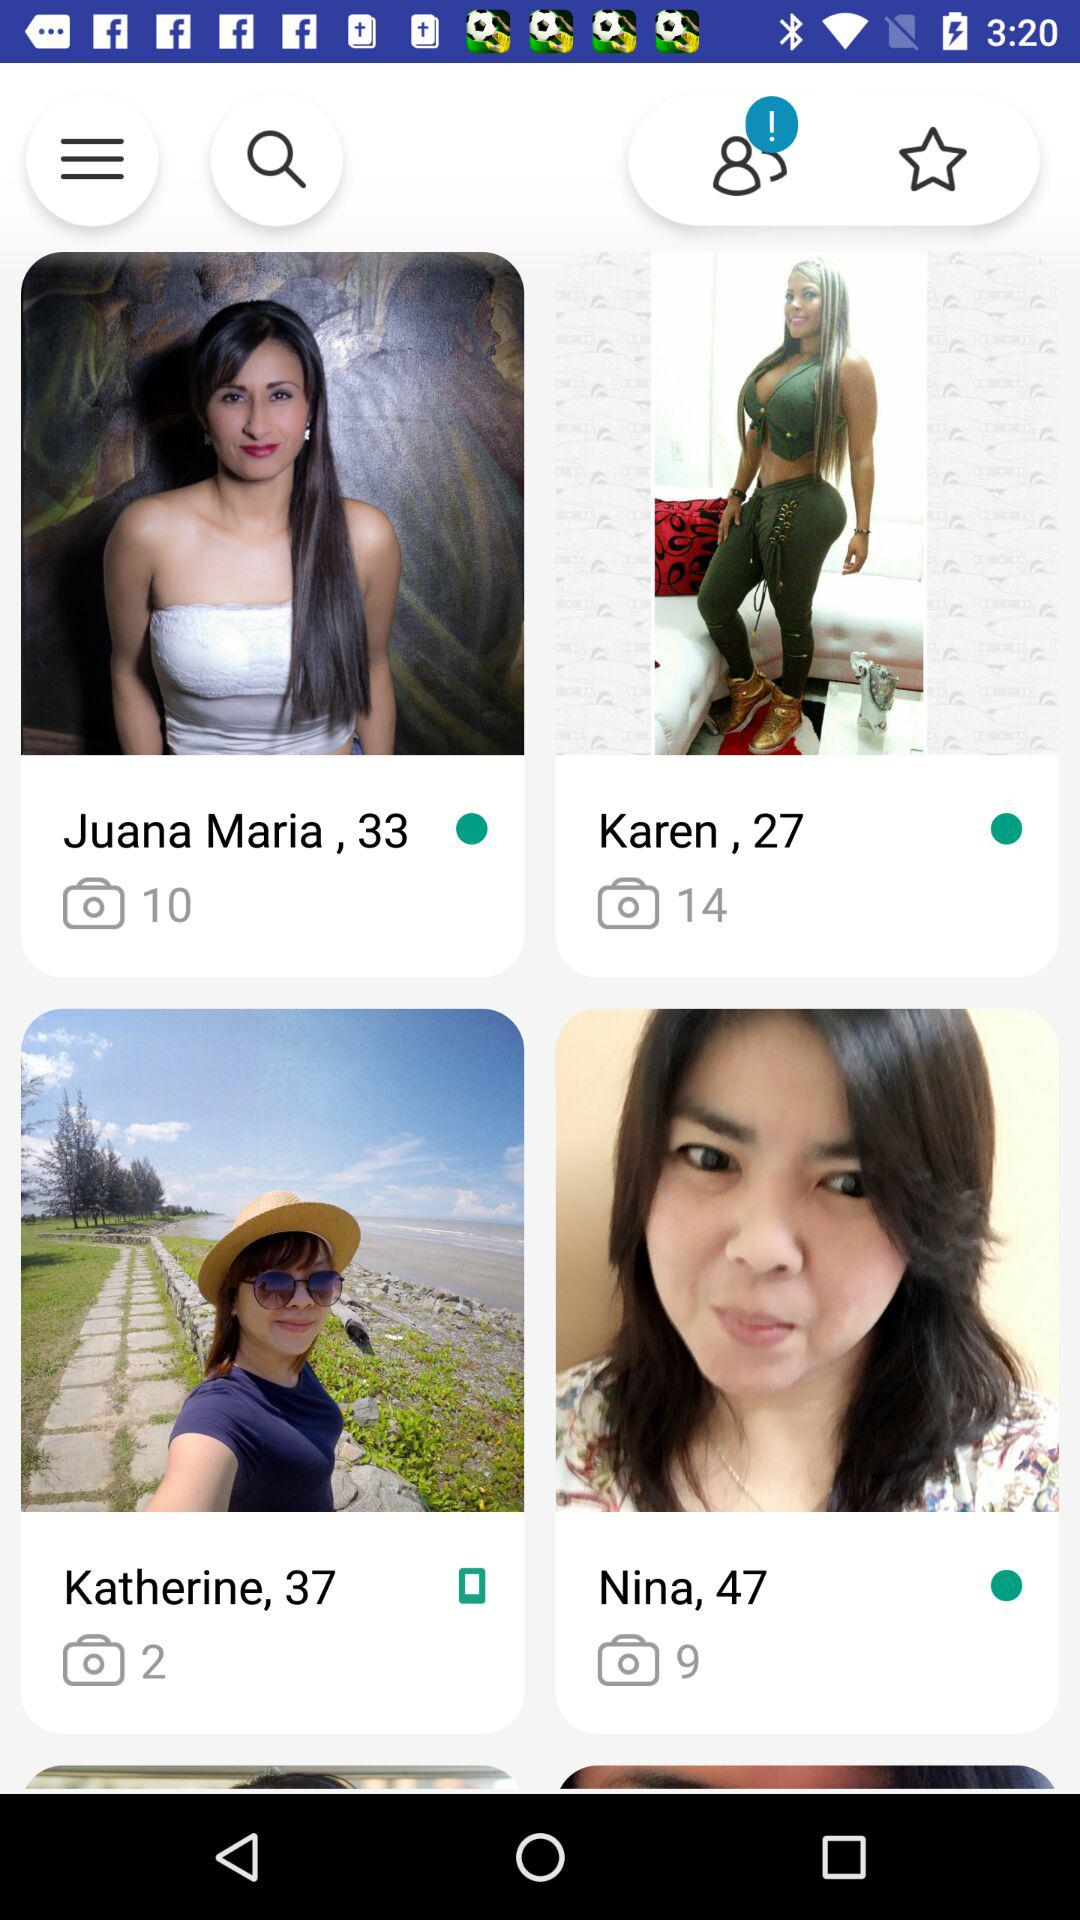Who is 33 years old?
Answer the question using a single word or phrase. The user is Juana Maria 